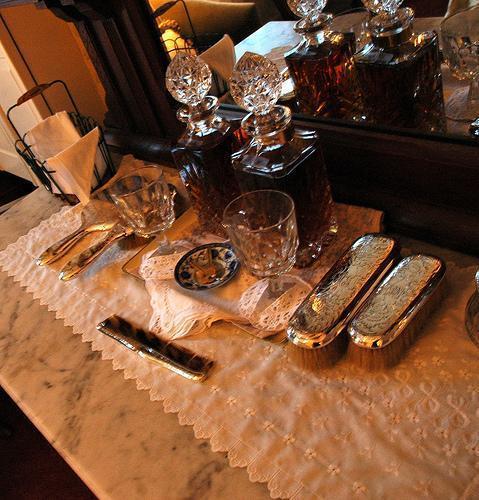How many brushes are on the counter?
Give a very brief answer. 3. How many glass decanters are there?
Give a very brief answer. 2. 